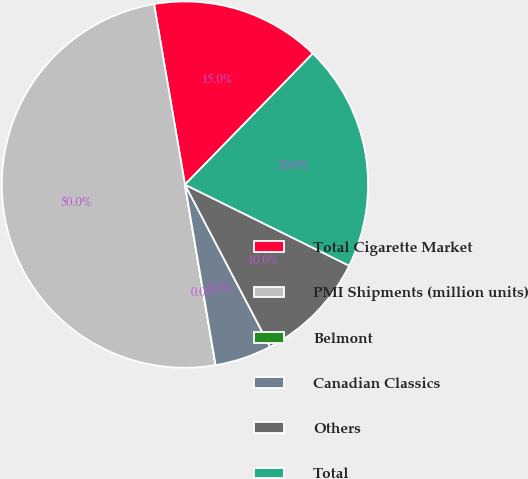<chart> <loc_0><loc_0><loc_500><loc_500><pie_chart><fcel>Total Cigarette Market<fcel>PMI Shipments (million units)<fcel>Belmont<fcel>Canadian Classics<fcel>Others<fcel>Total<nl><fcel>15.0%<fcel>49.97%<fcel>0.01%<fcel>5.01%<fcel>10.01%<fcel>20.0%<nl></chart> 